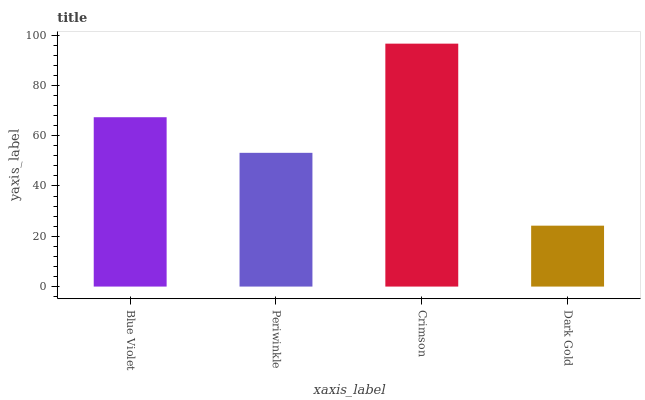Is Dark Gold the minimum?
Answer yes or no. Yes. Is Crimson the maximum?
Answer yes or no. Yes. Is Periwinkle the minimum?
Answer yes or no. No. Is Periwinkle the maximum?
Answer yes or no. No. Is Blue Violet greater than Periwinkle?
Answer yes or no. Yes. Is Periwinkle less than Blue Violet?
Answer yes or no. Yes. Is Periwinkle greater than Blue Violet?
Answer yes or no. No. Is Blue Violet less than Periwinkle?
Answer yes or no. No. Is Blue Violet the high median?
Answer yes or no. Yes. Is Periwinkle the low median?
Answer yes or no. Yes. Is Crimson the high median?
Answer yes or no. No. Is Crimson the low median?
Answer yes or no. No. 